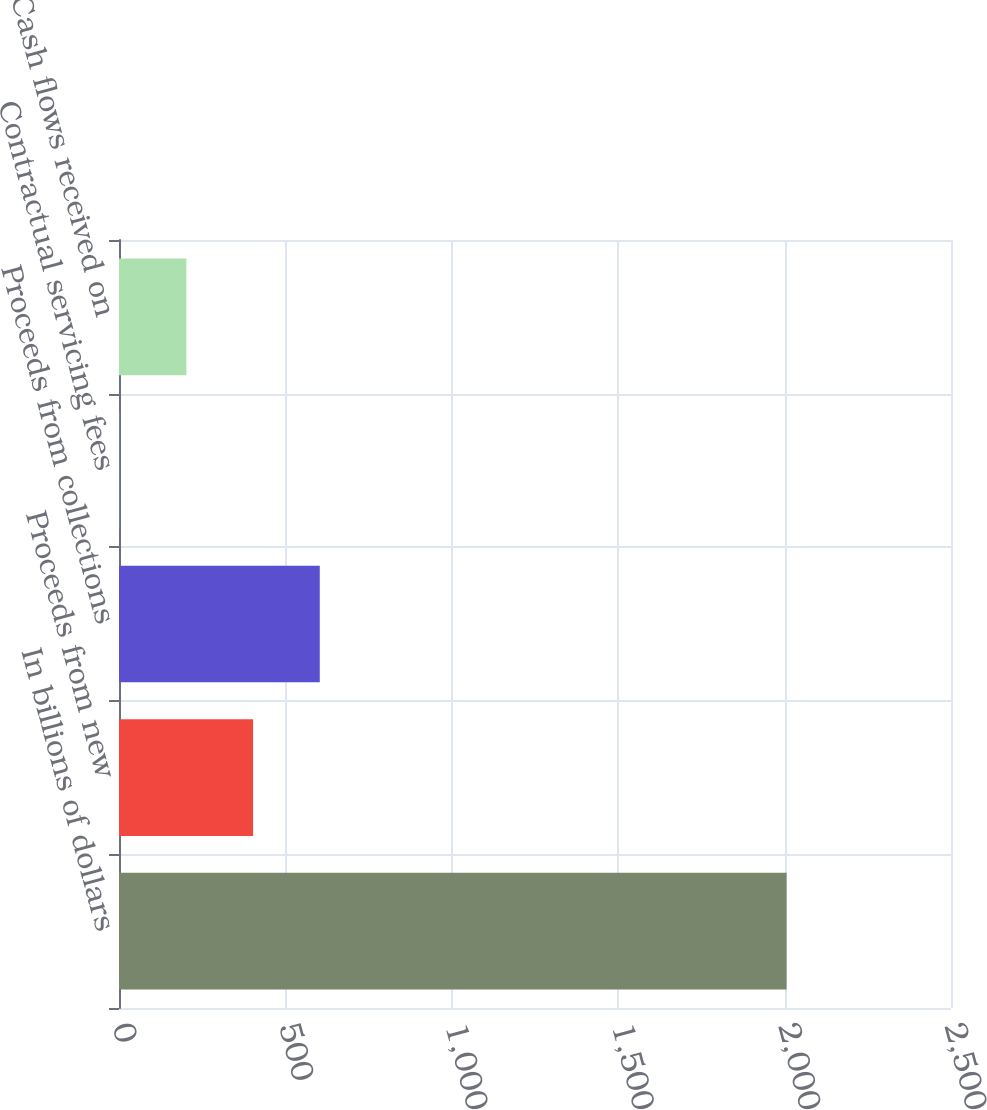Convert chart. <chart><loc_0><loc_0><loc_500><loc_500><bar_chart><fcel>In billions of dollars<fcel>Proceeds from new<fcel>Proceeds from collections<fcel>Contractual servicing fees<fcel>Cash flows received on<nl><fcel>2006<fcel>402.88<fcel>603.27<fcel>2.1<fcel>202.49<nl></chart> 